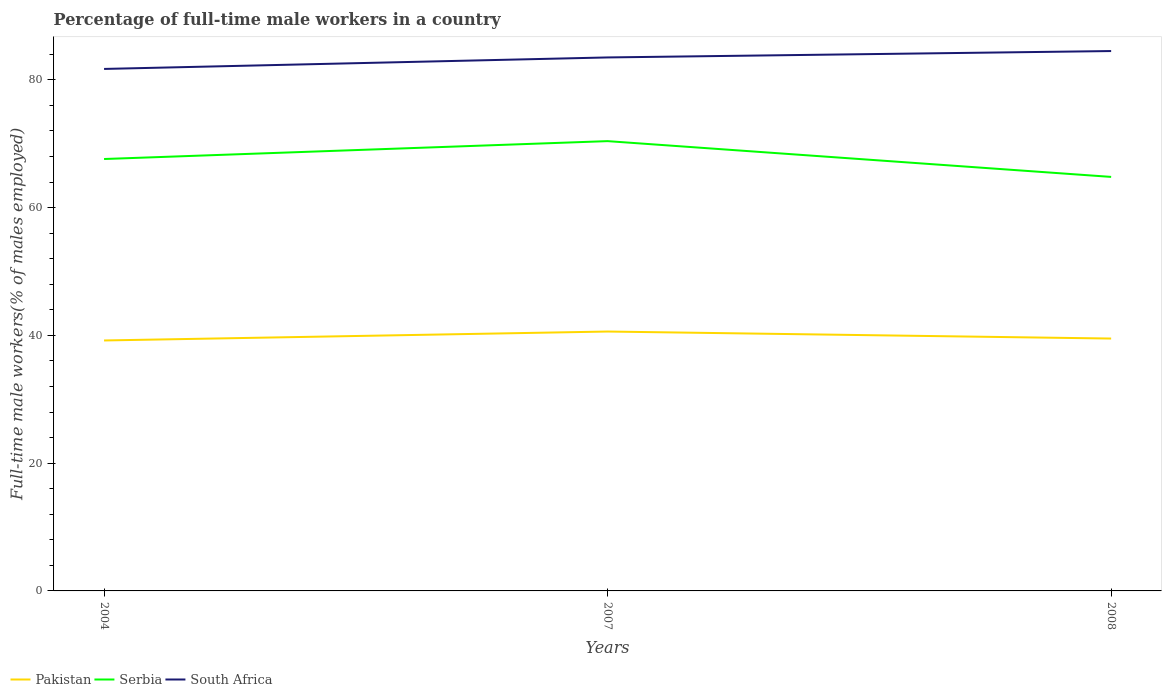How many different coloured lines are there?
Offer a very short reply. 3. Does the line corresponding to Pakistan intersect with the line corresponding to Serbia?
Provide a short and direct response. No. Across all years, what is the maximum percentage of full-time male workers in Serbia?
Provide a succinct answer. 64.8. In which year was the percentage of full-time male workers in Pakistan maximum?
Provide a succinct answer. 2004. What is the total percentage of full-time male workers in Serbia in the graph?
Your response must be concise. -2.8. What is the difference between the highest and the second highest percentage of full-time male workers in South Africa?
Provide a succinct answer. 2.8. What is the difference between the highest and the lowest percentage of full-time male workers in Pakistan?
Make the answer very short. 1. Is the percentage of full-time male workers in Serbia strictly greater than the percentage of full-time male workers in South Africa over the years?
Ensure brevity in your answer.  Yes. How many years are there in the graph?
Provide a short and direct response. 3. What is the difference between two consecutive major ticks on the Y-axis?
Your answer should be very brief. 20. Does the graph contain any zero values?
Make the answer very short. No. Does the graph contain grids?
Your answer should be compact. No. How are the legend labels stacked?
Provide a short and direct response. Horizontal. What is the title of the graph?
Keep it short and to the point. Percentage of full-time male workers in a country. What is the label or title of the X-axis?
Ensure brevity in your answer.  Years. What is the label or title of the Y-axis?
Keep it short and to the point. Full-time male workers(% of males employed). What is the Full-time male workers(% of males employed) of Pakistan in 2004?
Offer a very short reply. 39.2. What is the Full-time male workers(% of males employed) in Serbia in 2004?
Give a very brief answer. 67.6. What is the Full-time male workers(% of males employed) of South Africa in 2004?
Provide a succinct answer. 81.7. What is the Full-time male workers(% of males employed) in Pakistan in 2007?
Offer a terse response. 40.6. What is the Full-time male workers(% of males employed) in Serbia in 2007?
Offer a very short reply. 70.4. What is the Full-time male workers(% of males employed) of South Africa in 2007?
Your response must be concise. 83.5. What is the Full-time male workers(% of males employed) of Pakistan in 2008?
Give a very brief answer. 39.5. What is the Full-time male workers(% of males employed) in Serbia in 2008?
Keep it short and to the point. 64.8. What is the Full-time male workers(% of males employed) of South Africa in 2008?
Make the answer very short. 84.5. Across all years, what is the maximum Full-time male workers(% of males employed) of Pakistan?
Provide a short and direct response. 40.6. Across all years, what is the maximum Full-time male workers(% of males employed) of Serbia?
Offer a terse response. 70.4. Across all years, what is the maximum Full-time male workers(% of males employed) of South Africa?
Provide a succinct answer. 84.5. Across all years, what is the minimum Full-time male workers(% of males employed) of Pakistan?
Provide a short and direct response. 39.2. Across all years, what is the minimum Full-time male workers(% of males employed) in Serbia?
Keep it short and to the point. 64.8. Across all years, what is the minimum Full-time male workers(% of males employed) in South Africa?
Offer a very short reply. 81.7. What is the total Full-time male workers(% of males employed) of Pakistan in the graph?
Ensure brevity in your answer.  119.3. What is the total Full-time male workers(% of males employed) of Serbia in the graph?
Your answer should be compact. 202.8. What is the total Full-time male workers(% of males employed) in South Africa in the graph?
Provide a succinct answer. 249.7. What is the difference between the Full-time male workers(% of males employed) of Serbia in 2004 and that in 2007?
Give a very brief answer. -2.8. What is the difference between the Full-time male workers(% of males employed) of Serbia in 2004 and that in 2008?
Ensure brevity in your answer.  2.8. What is the difference between the Full-time male workers(% of males employed) of South Africa in 2004 and that in 2008?
Your answer should be very brief. -2.8. What is the difference between the Full-time male workers(% of males employed) in Pakistan in 2007 and that in 2008?
Keep it short and to the point. 1.1. What is the difference between the Full-time male workers(% of males employed) in Serbia in 2007 and that in 2008?
Your answer should be compact. 5.6. What is the difference between the Full-time male workers(% of males employed) of South Africa in 2007 and that in 2008?
Ensure brevity in your answer.  -1. What is the difference between the Full-time male workers(% of males employed) in Pakistan in 2004 and the Full-time male workers(% of males employed) in Serbia in 2007?
Offer a terse response. -31.2. What is the difference between the Full-time male workers(% of males employed) in Pakistan in 2004 and the Full-time male workers(% of males employed) in South Africa in 2007?
Offer a terse response. -44.3. What is the difference between the Full-time male workers(% of males employed) in Serbia in 2004 and the Full-time male workers(% of males employed) in South Africa in 2007?
Offer a very short reply. -15.9. What is the difference between the Full-time male workers(% of males employed) in Pakistan in 2004 and the Full-time male workers(% of males employed) in Serbia in 2008?
Keep it short and to the point. -25.6. What is the difference between the Full-time male workers(% of males employed) in Pakistan in 2004 and the Full-time male workers(% of males employed) in South Africa in 2008?
Make the answer very short. -45.3. What is the difference between the Full-time male workers(% of males employed) in Serbia in 2004 and the Full-time male workers(% of males employed) in South Africa in 2008?
Keep it short and to the point. -16.9. What is the difference between the Full-time male workers(% of males employed) in Pakistan in 2007 and the Full-time male workers(% of males employed) in Serbia in 2008?
Give a very brief answer. -24.2. What is the difference between the Full-time male workers(% of males employed) in Pakistan in 2007 and the Full-time male workers(% of males employed) in South Africa in 2008?
Provide a succinct answer. -43.9. What is the difference between the Full-time male workers(% of males employed) in Serbia in 2007 and the Full-time male workers(% of males employed) in South Africa in 2008?
Your response must be concise. -14.1. What is the average Full-time male workers(% of males employed) in Pakistan per year?
Offer a terse response. 39.77. What is the average Full-time male workers(% of males employed) of Serbia per year?
Provide a short and direct response. 67.6. What is the average Full-time male workers(% of males employed) in South Africa per year?
Your answer should be very brief. 83.23. In the year 2004, what is the difference between the Full-time male workers(% of males employed) of Pakistan and Full-time male workers(% of males employed) of Serbia?
Ensure brevity in your answer.  -28.4. In the year 2004, what is the difference between the Full-time male workers(% of males employed) of Pakistan and Full-time male workers(% of males employed) of South Africa?
Your answer should be compact. -42.5. In the year 2004, what is the difference between the Full-time male workers(% of males employed) of Serbia and Full-time male workers(% of males employed) of South Africa?
Provide a short and direct response. -14.1. In the year 2007, what is the difference between the Full-time male workers(% of males employed) in Pakistan and Full-time male workers(% of males employed) in Serbia?
Keep it short and to the point. -29.8. In the year 2007, what is the difference between the Full-time male workers(% of males employed) in Pakistan and Full-time male workers(% of males employed) in South Africa?
Provide a short and direct response. -42.9. In the year 2007, what is the difference between the Full-time male workers(% of males employed) in Serbia and Full-time male workers(% of males employed) in South Africa?
Provide a succinct answer. -13.1. In the year 2008, what is the difference between the Full-time male workers(% of males employed) in Pakistan and Full-time male workers(% of males employed) in Serbia?
Keep it short and to the point. -25.3. In the year 2008, what is the difference between the Full-time male workers(% of males employed) of Pakistan and Full-time male workers(% of males employed) of South Africa?
Provide a succinct answer. -45. In the year 2008, what is the difference between the Full-time male workers(% of males employed) in Serbia and Full-time male workers(% of males employed) in South Africa?
Offer a very short reply. -19.7. What is the ratio of the Full-time male workers(% of males employed) of Pakistan in 2004 to that in 2007?
Make the answer very short. 0.97. What is the ratio of the Full-time male workers(% of males employed) of Serbia in 2004 to that in 2007?
Ensure brevity in your answer.  0.96. What is the ratio of the Full-time male workers(% of males employed) of South Africa in 2004 to that in 2007?
Ensure brevity in your answer.  0.98. What is the ratio of the Full-time male workers(% of males employed) in Pakistan in 2004 to that in 2008?
Your answer should be very brief. 0.99. What is the ratio of the Full-time male workers(% of males employed) in Serbia in 2004 to that in 2008?
Provide a short and direct response. 1.04. What is the ratio of the Full-time male workers(% of males employed) in South Africa in 2004 to that in 2008?
Your answer should be very brief. 0.97. What is the ratio of the Full-time male workers(% of males employed) in Pakistan in 2007 to that in 2008?
Provide a short and direct response. 1.03. What is the ratio of the Full-time male workers(% of males employed) of Serbia in 2007 to that in 2008?
Provide a succinct answer. 1.09. What is the ratio of the Full-time male workers(% of males employed) of South Africa in 2007 to that in 2008?
Offer a very short reply. 0.99. What is the difference between the highest and the second highest Full-time male workers(% of males employed) of Pakistan?
Your answer should be very brief. 1.1. What is the difference between the highest and the second highest Full-time male workers(% of males employed) of Serbia?
Offer a terse response. 2.8. What is the difference between the highest and the second highest Full-time male workers(% of males employed) in South Africa?
Make the answer very short. 1. What is the difference between the highest and the lowest Full-time male workers(% of males employed) in South Africa?
Keep it short and to the point. 2.8. 